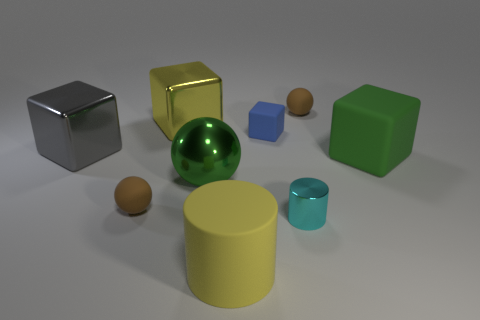What number of objects are balls that are left of the cyan shiny cylinder or brown matte things that are behind the gray block?
Your answer should be very brief. 3. What number of other objects are the same color as the small shiny object?
Offer a very short reply. 0. There is a tiny brown rubber thing right of the yellow shiny block; is it the same shape as the tiny blue matte thing?
Your answer should be very brief. No. Are there fewer matte blocks to the left of the green sphere than small green balls?
Give a very brief answer. No. Is there a tiny gray cylinder made of the same material as the blue object?
Your answer should be very brief. No. There is a yellow cylinder that is the same size as the gray metallic object; what is its material?
Keep it short and to the point. Rubber. Is the number of brown balls that are on the left side of the small cyan cylinder less than the number of cylinders right of the yellow shiny thing?
Make the answer very short. Yes. What shape is the large metallic object that is both in front of the yellow metal object and right of the gray block?
Provide a short and direct response. Sphere. How many other big objects have the same shape as the big gray thing?
Give a very brief answer. 2. There is a green cube that is made of the same material as the blue thing; what size is it?
Offer a very short reply. Large. 